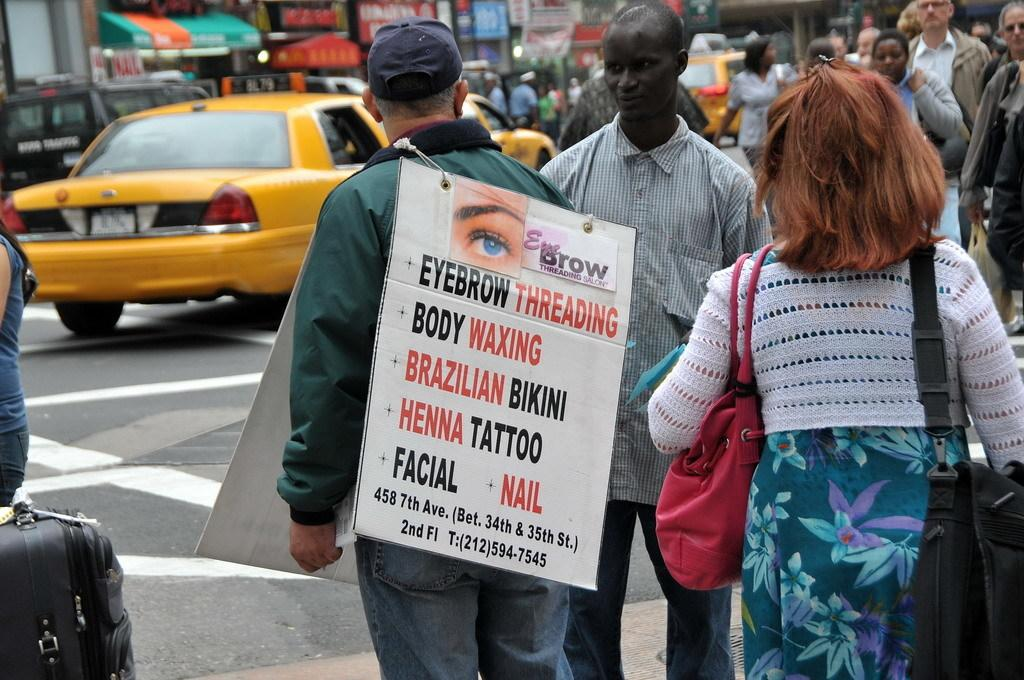<image>
Render a clear and concise summary of the photo. A crowd of people are walking down a busy street and a man is wearing a sign that says Eyebrow Threading. 